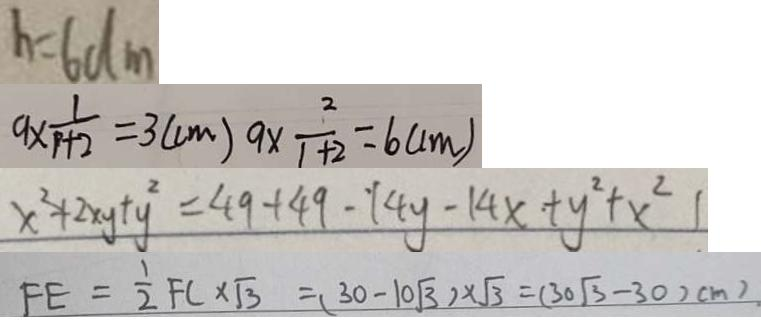<formula> <loc_0><loc_0><loc_500><loc_500>h = 6 d m 
 9 \times \frac { 1 } { p + 2 } = 3 ( c m ) 9 \times \frac { 2 } { 1 + 2 } = 6 ( c m ) 
 x ^ { 2 } + 2 x y + y ^ { 2 } = 4 9 + 4 9 - 1 4 y - 1 4 x + y ^ { 2 } + x ^ { 2 } 1 
 F E = \frac { 1 } { 2 } F C \times \sqrt { 3 } = ( 3 0 - 1 0 \sqrt { 3 } ) \times \sqrt { 3 } = ( 3 0 \sqrt { 3 } - 3 0 ) c m )</formula> 